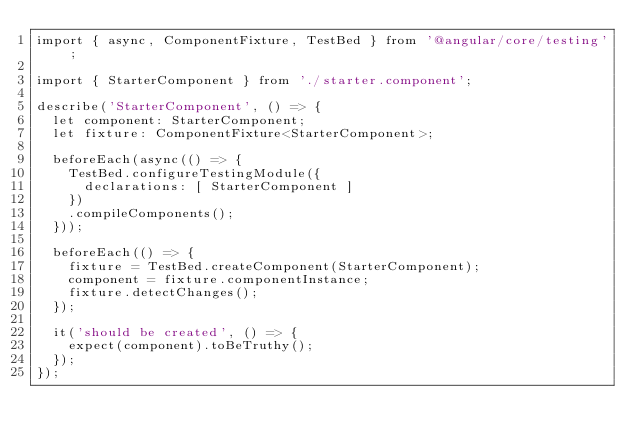Convert code to text. <code><loc_0><loc_0><loc_500><loc_500><_TypeScript_>import { async, ComponentFixture, TestBed } from '@angular/core/testing';

import { StarterComponent } from './starter.component';

describe('StarterComponent', () => {
  let component: StarterComponent;
  let fixture: ComponentFixture<StarterComponent>;

  beforeEach(async(() => {
    TestBed.configureTestingModule({
      declarations: [ StarterComponent ]
    })
    .compileComponents();
  }));

  beforeEach(() => {
    fixture = TestBed.createComponent(StarterComponent);
    component = fixture.componentInstance;
    fixture.detectChanges();
  });

  it('should be created', () => {
    expect(component).toBeTruthy();
  });
});
</code> 